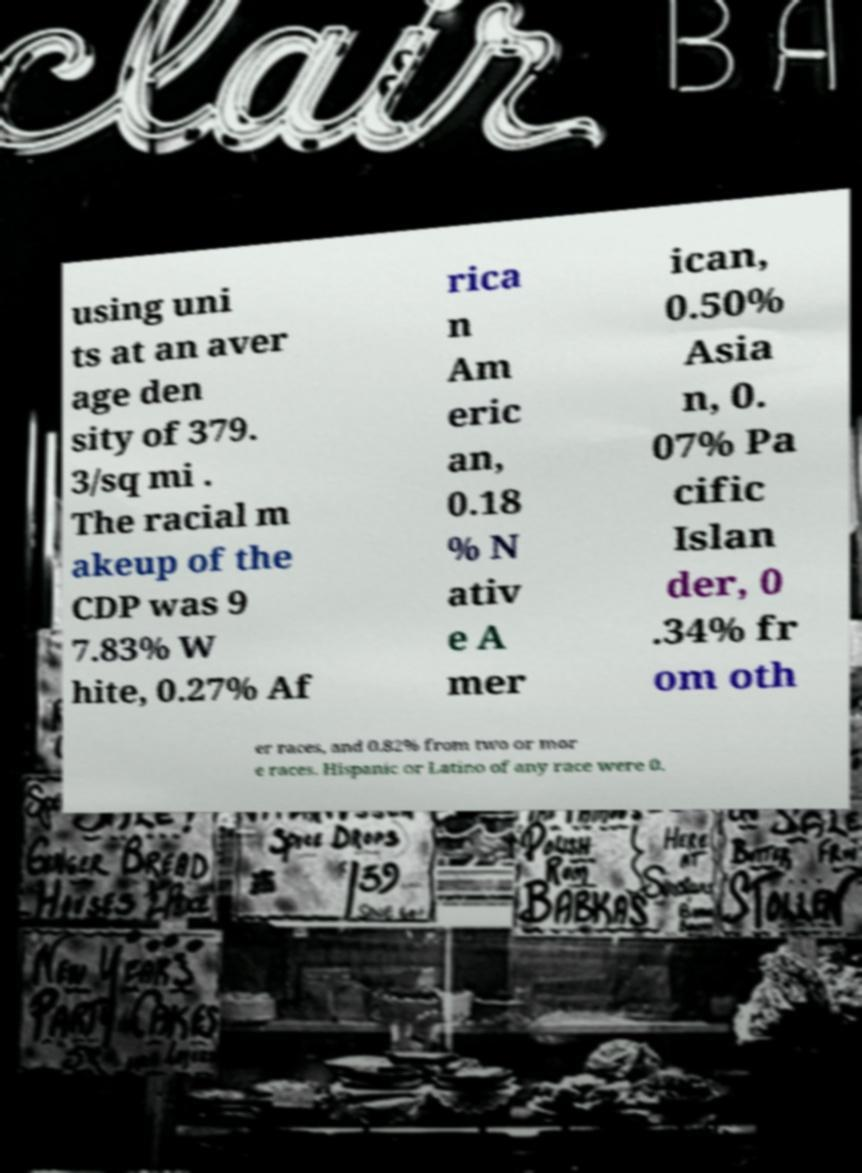Please read and relay the text visible in this image. What does it say? using uni ts at an aver age den sity of 379. 3/sq mi . The racial m akeup of the CDP was 9 7.83% W hite, 0.27% Af rica n Am eric an, 0.18 % N ativ e A mer ican, 0.50% Asia n, 0. 07% Pa cific Islan der, 0 .34% fr om oth er races, and 0.82% from two or mor e races. Hispanic or Latino of any race were 0. 